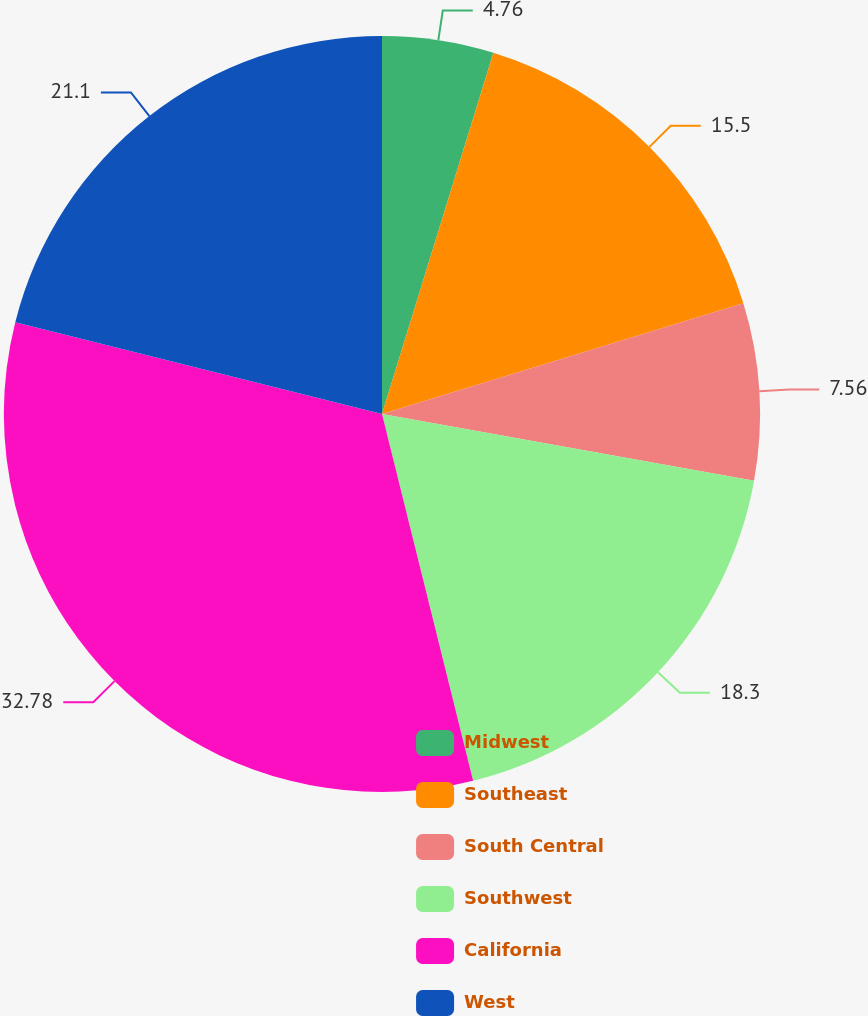Convert chart to OTSL. <chart><loc_0><loc_0><loc_500><loc_500><pie_chart><fcel>Midwest<fcel>Southeast<fcel>South Central<fcel>Southwest<fcel>California<fcel>West<nl><fcel>4.76%<fcel>15.5%<fcel>7.56%<fcel>18.3%<fcel>32.77%<fcel>21.1%<nl></chart> 